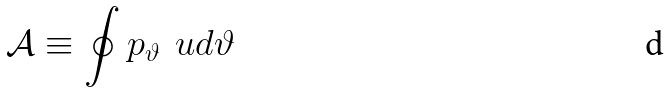Convert formula to latex. <formula><loc_0><loc_0><loc_500><loc_500>\mathcal { A } \equiv \oint p _ { \vartheta } \, \ u d \vartheta</formula> 